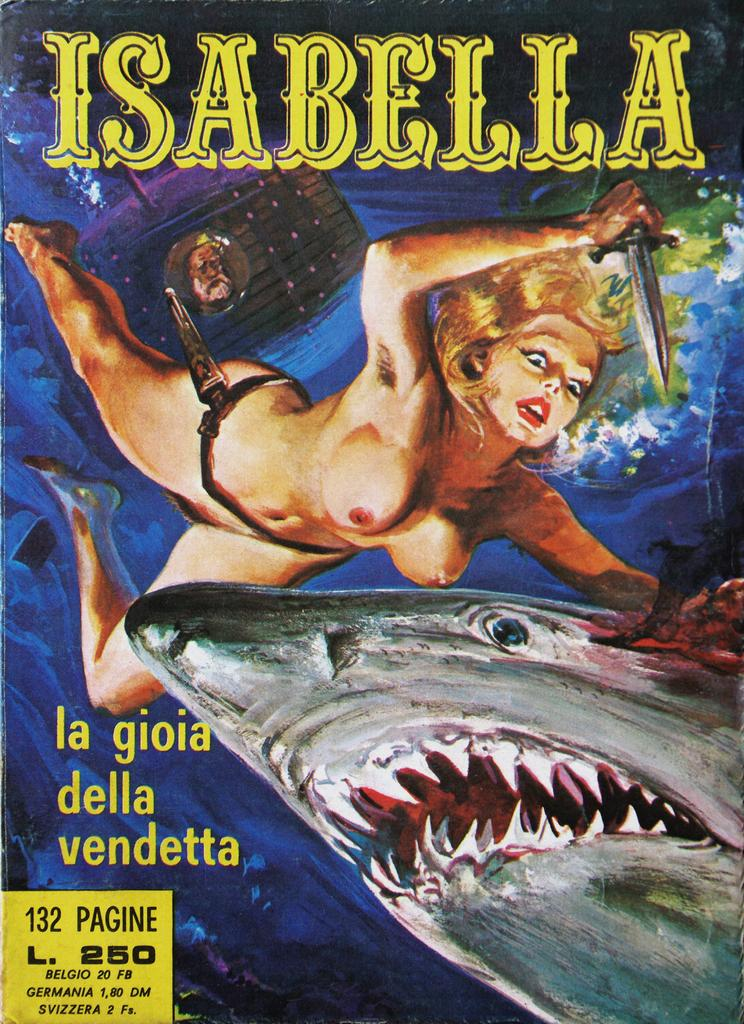What is depicted on the poster in the picture? The poster features a woman and a water animal. Where is the woman located in relation to the water animal on the poster? The provided facts do not specify the exact position of the woman and the water animal on the poster. What is written at the top of the picture? There is text at the top of the picture. What is written at the bottom of the picture? There is text at the bottom of the picture. How many ants are crawling on the woman's hair in the image? There are no ants or hair present in the image; the poster features a woman and a water animal. 